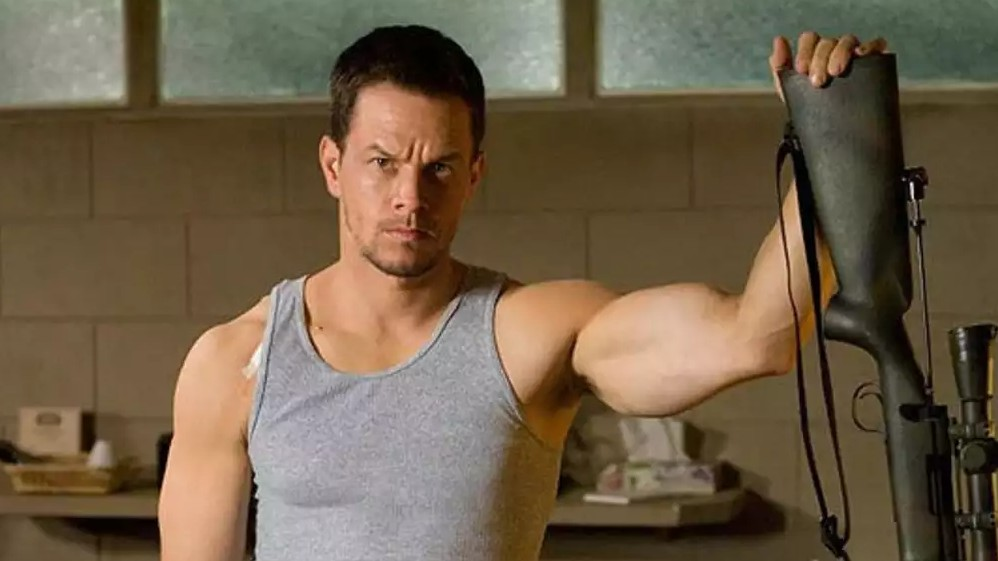Explain the visual content of the image in great detail. In the image, we see an actor standing in an indoor setting, which seems to be a room with a large window visible in the background, allowing natural light to filter in. The setting is simple, with the background comprising beige brick walls and some shelves or tables, suggesting it might be a part of a home gym or a casual room setup. The actor is wearing a gray tank top that highlights his muscular physique, particularly his well-defined arms. He is holding what appears to be the stock of a black rifle in his right hand, his left arm flexed, further accentuating his strength. His facial expression is serious, with a focused gaze slightly off to the side, possibly indicating a moment of tension or contemplation. The overall atmosphere of the image conveys a sense of readiness or anticipation as if he is preparing for an imminent action. 